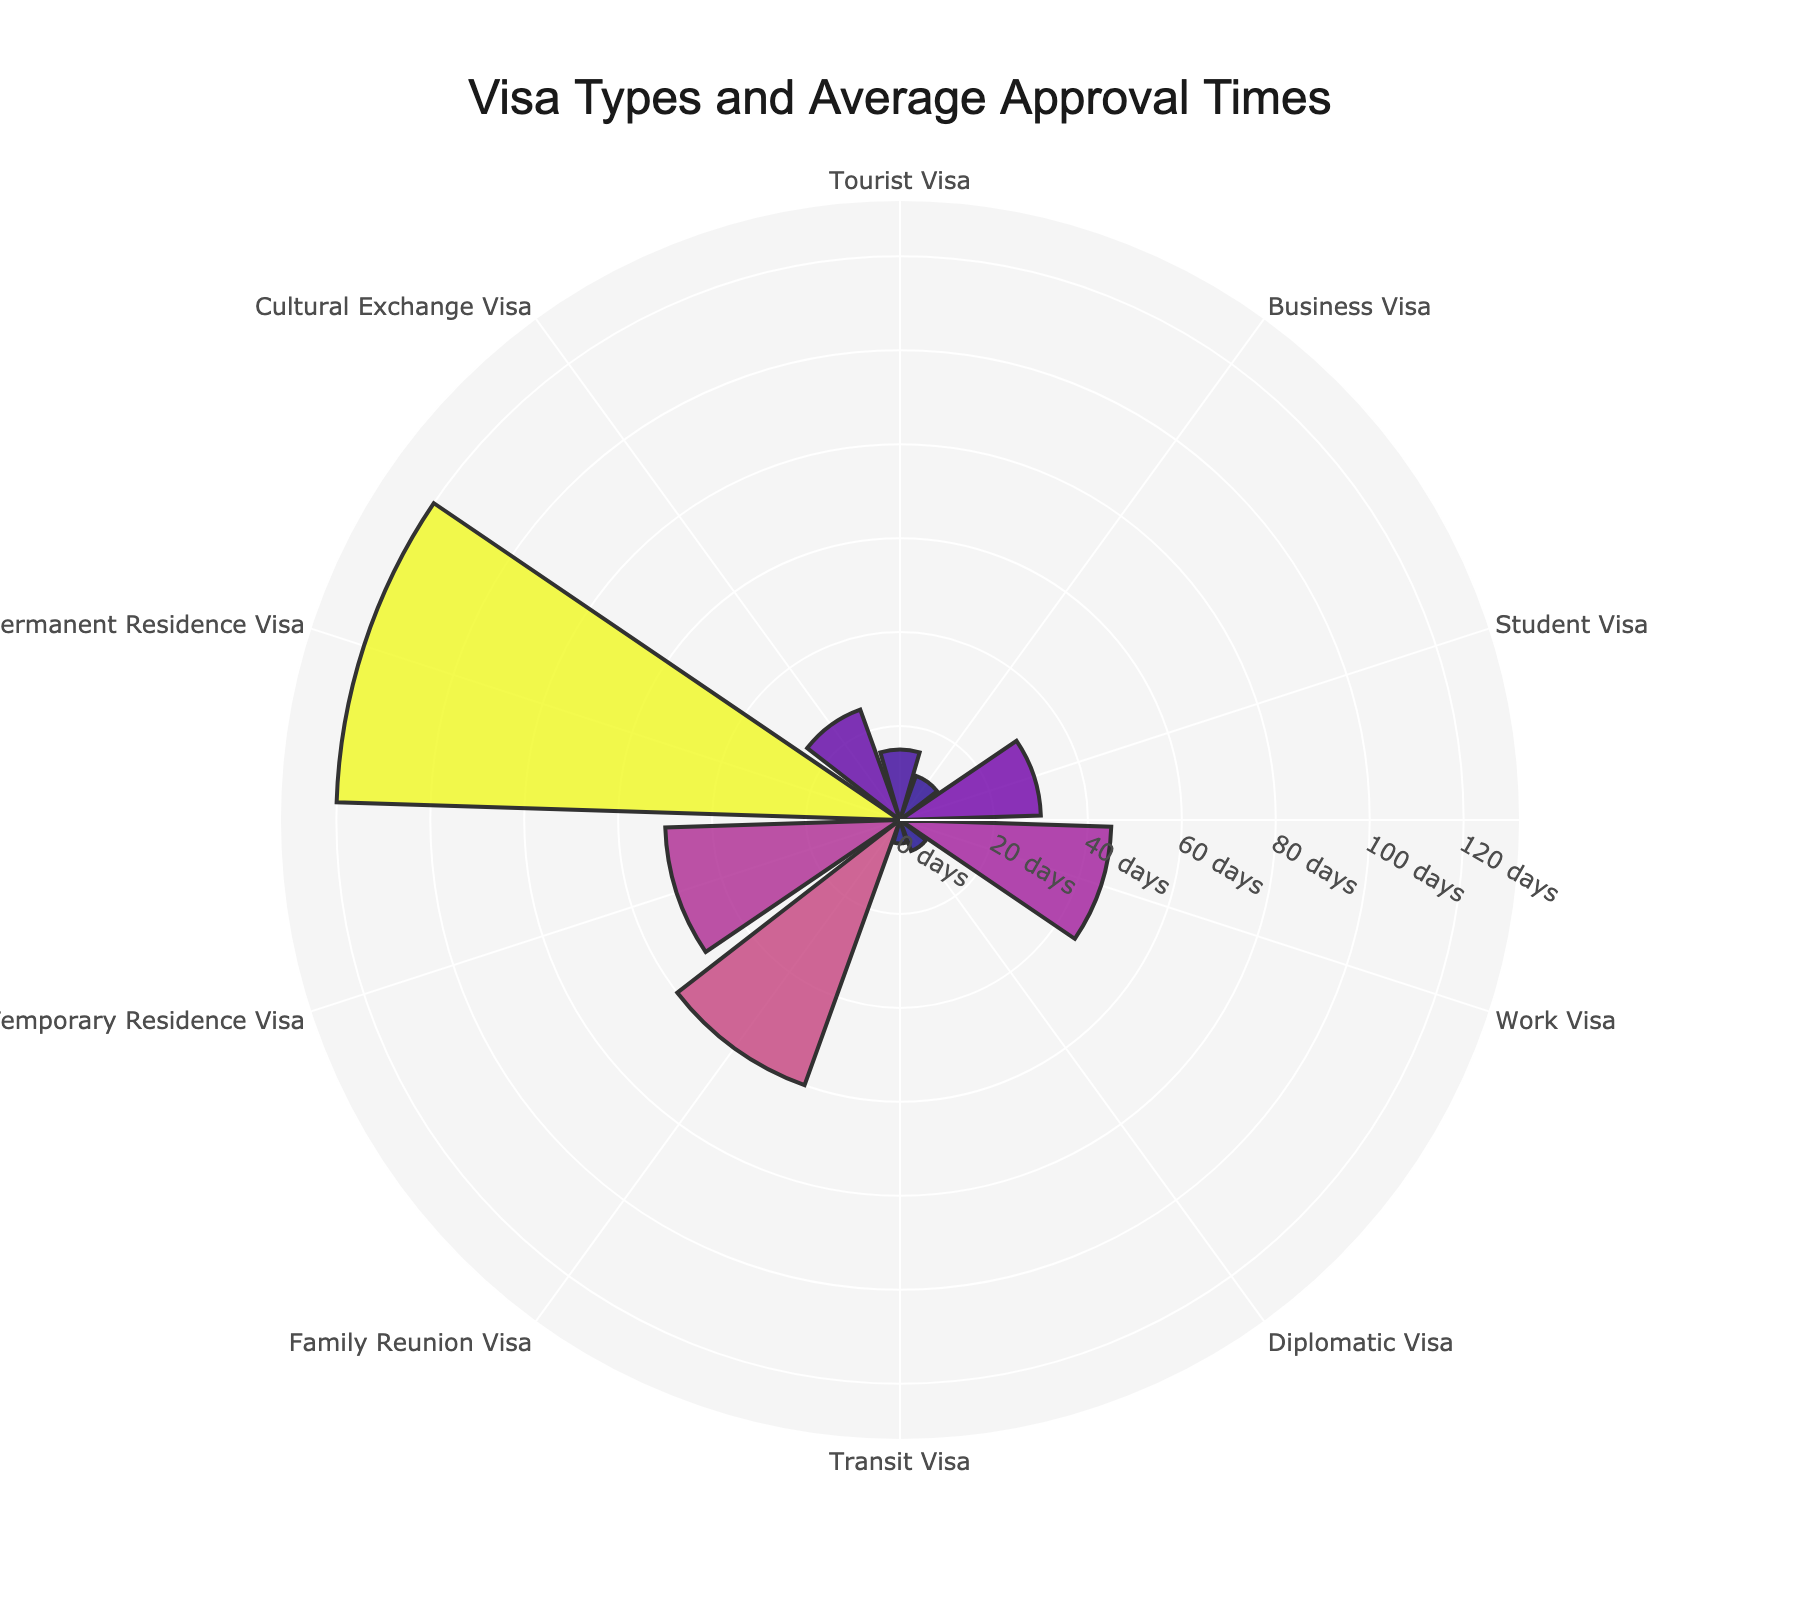What's the title of the chart? The title of the chart is located at the top and is often the largest text present. In this chart, it's centered and says “Visa Types and Average Approval Times.”
Answer: Visa Types and Average Approval Times How many visa types are represented in the chart? Each line or sector in the polar area chart represents a different visa type. You can count these lines to determine the number of visa types.
Answer: 10 Which visa type has the shortest average approval time? The shortest bar or sector in the polar area chart indicates the shortest average approval time. In this chart, the shortest bar is labeled "Transit Visa."
Answer: Transit Visa Which visa type has the longest average approval time? The longest bar or sector in the polar area chart indicates the longest average approval time. In the chart, the longest bar is labeled "Permanent Residence Visa."
Answer: Permanent Residence Visa What is the range of approval times shown in the chart? To find the range, subtract the shortest approval time from the longest approval time. The shortest approval time is 5 days (Transit Visa), and the longest is 120 days (Permanent Residence Visa). So, 120 - 5 = 115.
Answer: 115 days What is the average approval time for a Work Visa? Look at the bar labeled "Work Visa" and read the radial distance to get its value, which is 45 days.
Answer: 45 days How much longer is the approval time for a Family Reunion Visa compared to a Tourist Visa? Subtract the approval time for the Tourist Visa from the approval time for the Family Reunion Visa. Family Reunion Visa is 60 days, and Tourist Visa is 15 days, so 60 - 15 = 45 days.
Answer: 45 days Which visa types have an approval time of 30 days or more? Look for bars or sectors that extend to at least 30 days. The visa types are Student Visa (30 days), Work Visa (45 days), Family Reunion Visa (60 days), Temporary Residence Visa (50 days), Permanent Residence Visa (120 days), and Cultural Exchange Visa (25 days).
Answer: Student Visa, Work Visa, Family Reunion Visa, Temporary Residence Visa, Permanent Residence Visa How does the approval time for a Diplomatic Visa compare with a Business Visa? Compare the radial distances of the bars for both visa types. Diplomatic Visa is 7 days and Business Visa is 10 days. The Diplomatic Visa has a shorter approval time.
Answer: Diplomatic Visa has a shorter approval time What is the average approval time for visas that take less than 20 days? Identify the visas with approval times less than 20 days: Tourist Visa (15), Business Visa (10), Diplomatic Visa (7), and Transit Visa (5). Sum these times and divide by the number of visas (15 + 10 + 7 + 5 = 37; 37 / 4 = 9.25 days).
Answer: 9.25 days 